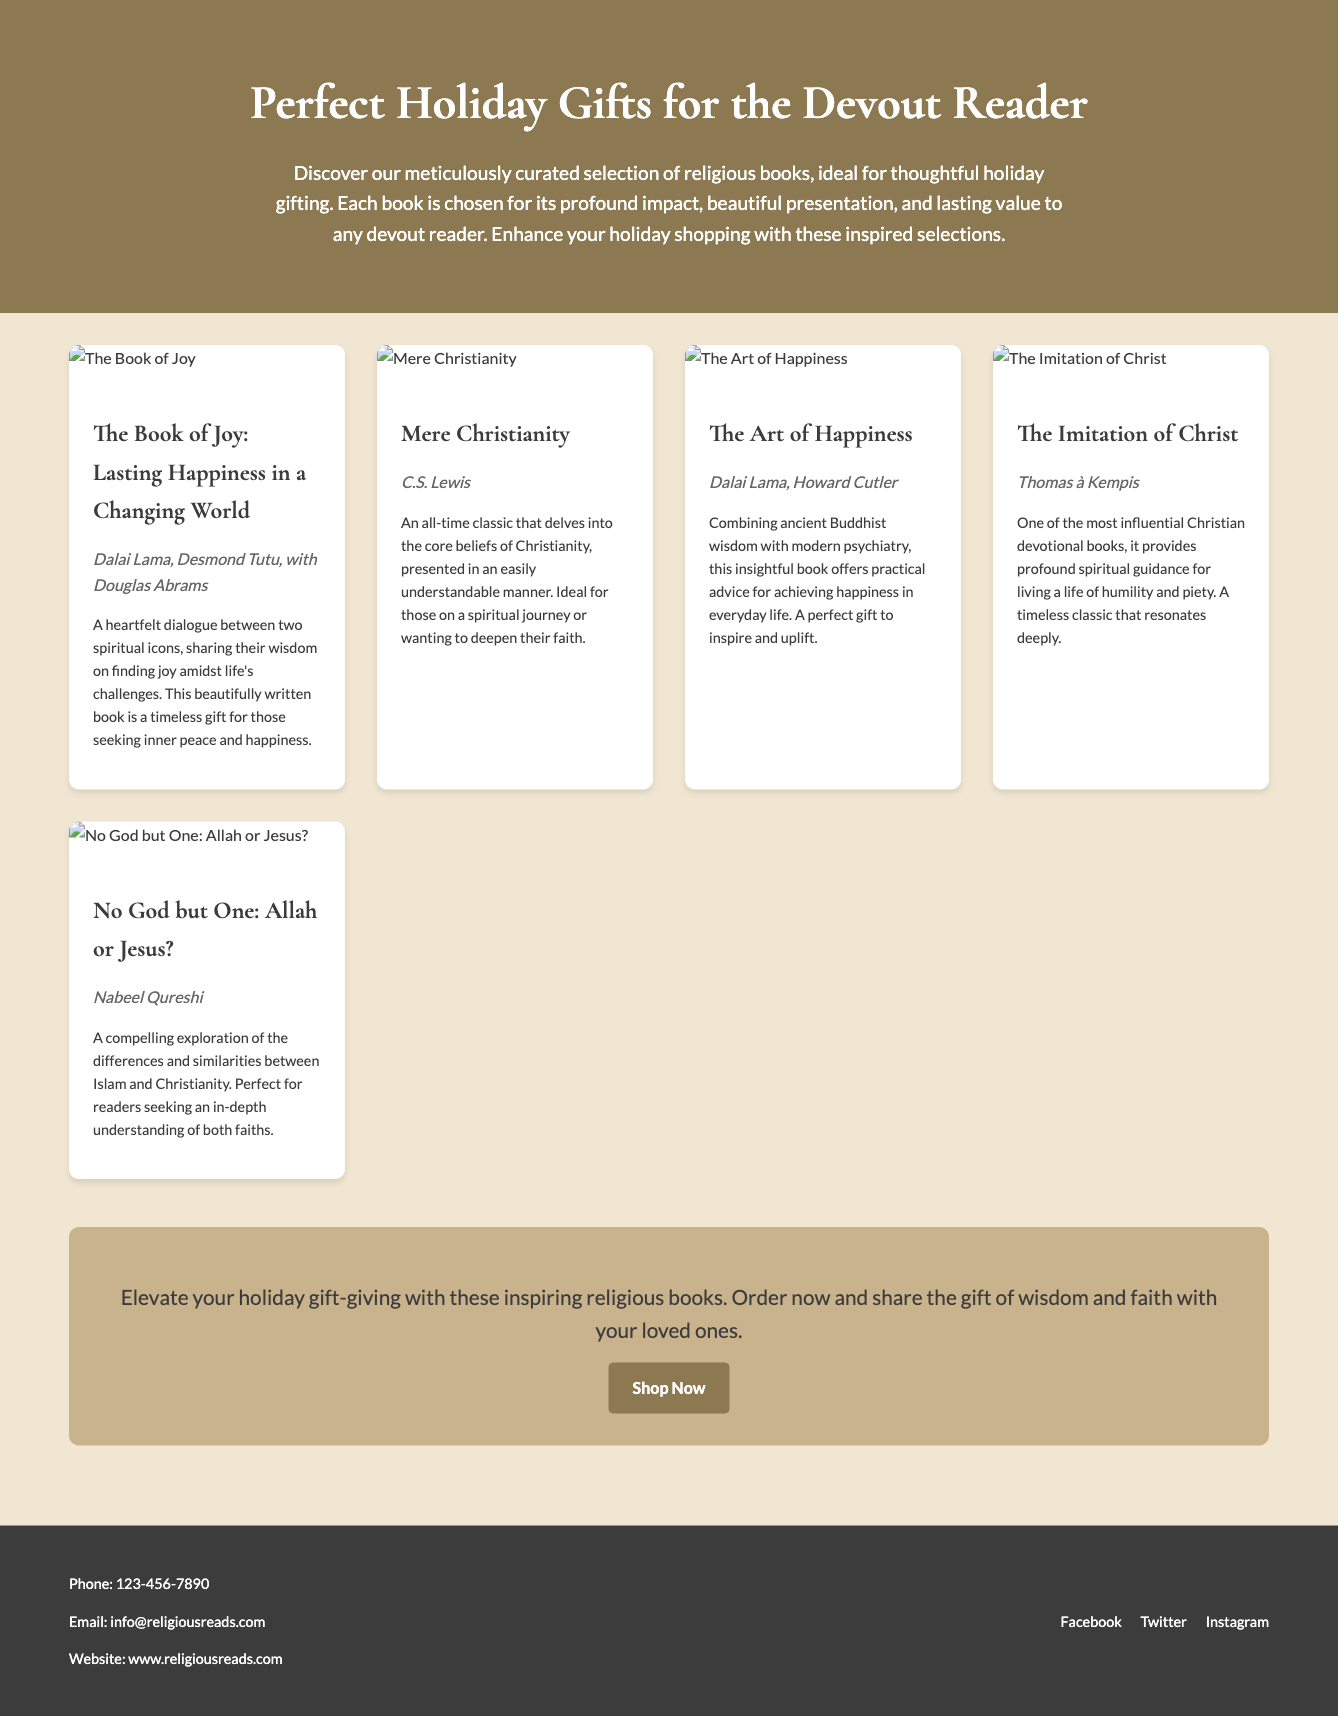What is the title of the advertisement? The title is prominently displayed at the top of the advertisement, reading "Perfect Holiday Gifts for the Devout Reader."
Answer: Perfect Holiday Gifts for the Devout Reader Who authored "Mere Christianity"? The author of "Mere Christianity" is listed in the book card section of the advertisement.
Answer: C.S. Lewis How many books are featured in the advertisement? The advertisement lists a total of five books in the book grid section.
Answer: 5 What is the theme of the selected books? The introduction hints at the theme of the books being related to spirituality, wisdom, and religious teachings.
Answer: Religious Which book discusses the differences between Islam and Christianity? The book information describes which book addresses the topic of Islam and Christianity.
Answer: No God but One: Allah or Jesus? What is the main call to action in the advertisement? The call to action encourages readers to take advantage of the holiday gift offerings with an order prompt.
Answer: Shop Now What element enhances the shopping experience according to the advertisement? The advertisement emphasizes that the layout is designed to enhance the ease of shopping and reading.
Answer: Easy-to-read layout Who are the authors of "The Book of Joy"? The book card provides details about the authors of "The Book of Joy."
Answer: Dalai Lama, Desmond Tutu, with Douglas Abrams What type of books are included in the holiday gift guide? The advertisement categorizes the types of books as being religious and spiritual in nature.
Answer: Religious books 